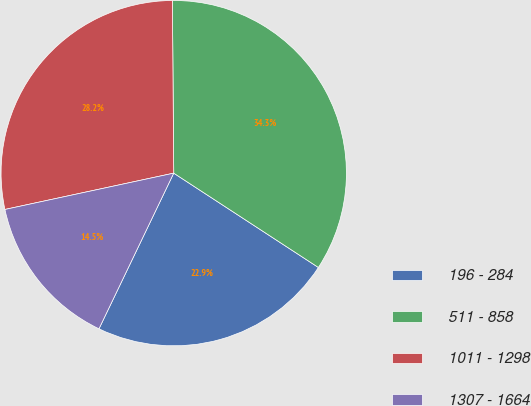<chart> <loc_0><loc_0><loc_500><loc_500><pie_chart><fcel>196 - 284<fcel>511 - 858<fcel>1011 - 1298<fcel>1307 - 1664<nl><fcel>22.93%<fcel>34.32%<fcel>28.25%<fcel>14.5%<nl></chart> 